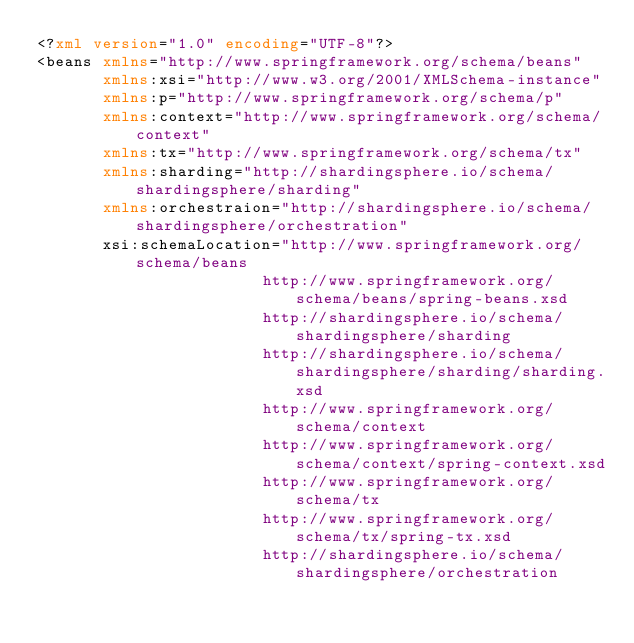<code> <loc_0><loc_0><loc_500><loc_500><_XML_><?xml version="1.0" encoding="UTF-8"?>
<beans xmlns="http://www.springframework.org/schema/beans"
       xmlns:xsi="http://www.w3.org/2001/XMLSchema-instance"
       xmlns:p="http://www.springframework.org/schema/p"
       xmlns:context="http://www.springframework.org/schema/context"
       xmlns:tx="http://www.springframework.org/schema/tx"
       xmlns:sharding="http://shardingsphere.io/schema/shardingsphere/sharding"
       xmlns:orchestraion="http://shardingsphere.io/schema/shardingsphere/orchestration"
       xsi:schemaLocation="http://www.springframework.org/schema/beans 
                        http://www.springframework.org/schema/beans/spring-beans.xsd
                        http://shardingsphere.io/schema/shardingsphere/sharding
                        http://shardingsphere.io/schema/shardingsphere/sharding/sharding.xsd
                        http://www.springframework.org/schema/context
                        http://www.springframework.org/schema/context/spring-context.xsd
                        http://www.springframework.org/schema/tx
                        http://www.springframework.org/schema/tx/spring-tx.xsd
                        http://shardingsphere.io/schema/shardingsphere/orchestration</code> 